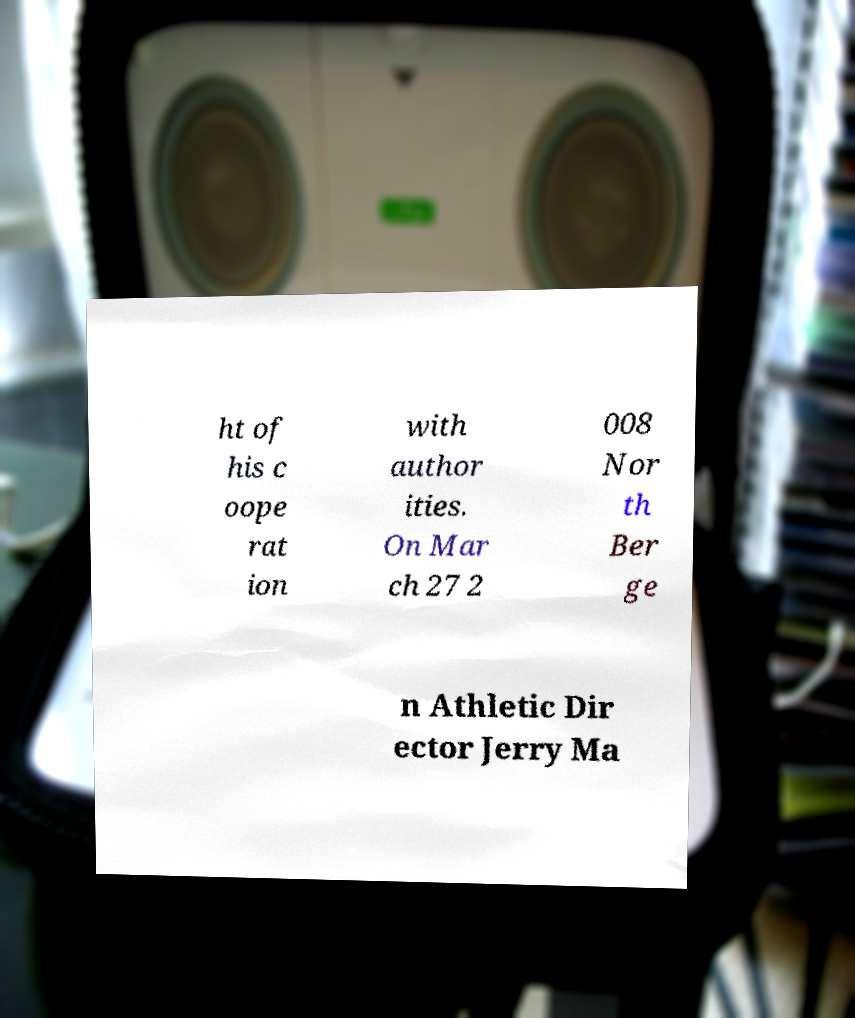Can you read and provide the text displayed in the image?This photo seems to have some interesting text. Can you extract and type it out for me? ht of his c oope rat ion with author ities. On Mar ch 27 2 008 Nor th Ber ge n Athletic Dir ector Jerry Ma 